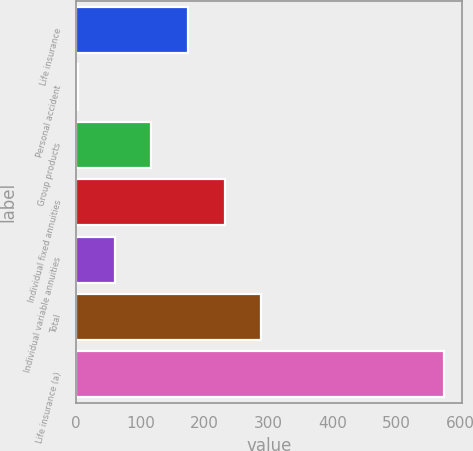Convert chart. <chart><loc_0><loc_0><loc_500><loc_500><bar_chart><fcel>Life insurance<fcel>Personal accident<fcel>Group products<fcel>Individual fixed annuities<fcel>Individual variable annuities<fcel>Total<fcel>Life insurance (a)<nl><fcel>174.3<fcel>3<fcel>117.2<fcel>231.4<fcel>60.1<fcel>288.5<fcel>574<nl></chart> 